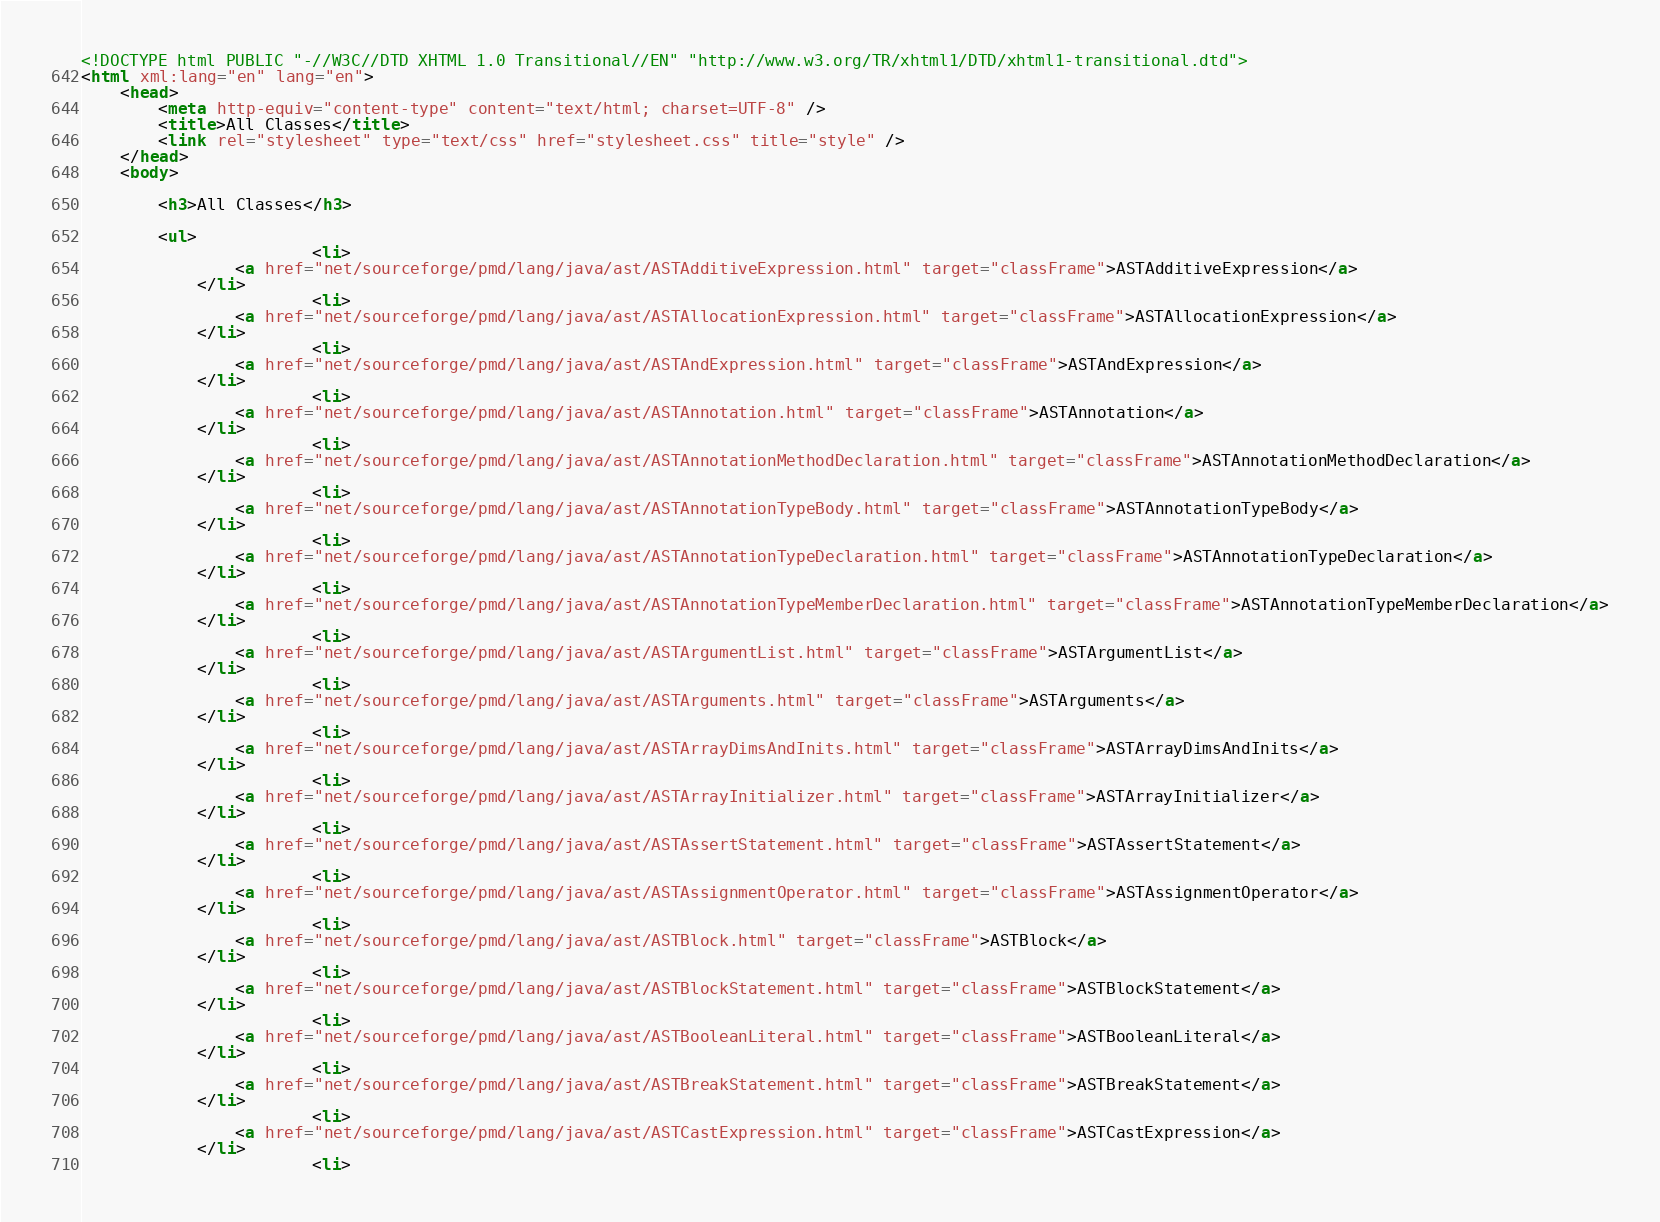Convert code to text. <code><loc_0><loc_0><loc_500><loc_500><_HTML_>
<!DOCTYPE html PUBLIC "-//W3C//DTD XHTML 1.0 Transitional//EN" "http://www.w3.org/TR/xhtml1/DTD/xhtml1-transitional.dtd">
<html xml:lang="en" lang="en">
	<head>
		<meta http-equiv="content-type" content="text/html; charset=UTF-8" />
		<title>All Classes</title>
		<link rel="stylesheet" type="text/css" href="stylesheet.css" title="style" />
    </head>
    <body>

		<h3>All Classes</h3>

		<ul>
						<li>
				<a href="net/sourceforge/pmd/lang/java/ast/ASTAdditiveExpression.html" target="classFrame">ASTAdditiveExpression</a>
			</li>
						<li>
				<a href="net/sourceforge/pmd/lang/java/ast/ASTAllocationExpression.html" target="classFrame">ASTAllocationExpression</a>
			</li>
						<li>
				<a href="net/sourceforge/pmd/lang/java/ast/ASTAndExpression.html" target="classFrame">ASTAndExpression</a>
			</li>
						<li>
				<a href="net/sourceforge/pmd/lang/java/ast/ASTAnnotation.html" target="classFrame">ASTAnnotation</a>
			</li>
						<li>
				<a href="net/sourceforge/pmd/lang/java/ast/ASTAnnotationMethodDeclaration.html" target="classFrame">ASTAnnotationMethodDeclaration</a>
			</li>
						<li>
				<a href="net/sourceforge/pmd/lang/java/ast/ASTAnnotationTypeBody.html" target="classFrame">ASTAnnotationTypeBody</a>
			</li>
						<li>
				<a href="net/sourceforge/pmd/lang/java/ast/ASTAnnotationTypeDeclaration.html" target="classFrame">ASTAnnotationTypeDeclaration</a>
			</li>
						<li>
				<a href="net/sourceforge/pmd/lang/java/ast/ASTAnnotationTypeMemberDeclaration.html" target="classFrame">ASTAnnotationTypeMemberDeclaration</a>
			</li>
						<li>
				<a href="net/sourceforge/pmd/lang/java/ast/ASTArgumentList.html" target="classFrame">ASTArgumentList</a>
			</li>
						<li>
				<a href="net/sourceforge/pmd/lang/java/ast/ASTArguments.html" target="classFrame">ASTArguments</a>
			</li>
						<li>
				<a href="net/sourceforge/pmd/lang/java/ast/ASTArrayDimsAndInits.html" target="classFrame">ASTArrayDimsAndInits</a>
			</li>
						<li>
				<a href="net/sourceforge/pmd/lang/java/ast/ASTArrayInitializer.html" target="classFrame">ASTArrayInitializer</a>
			</li>
						<li>
				<a href="net/sourceforge/pmd/lang/java/ast/ASTAssertStatement.html" target="classFrame">ASTAssertStatement</a>
			</li>
						<li>
				<a href="net/sourceforge/pmd/lang/java/ast/ASTAssignmentOperator.html" target="classFrame">ASTAssignmentOperator</a>
			</li>
						<li>
				<a href="net/sourceforge/pmd/lang/java/ast/ASTBlock.html" target="classFrame">ASTBlock</a>
			</li>
						<li>
				<a href="net/sourceforge/pmd/lang/java/ast/ASTBlockStatement.html" target="classFrame">ASTBlockStatement</a>
			</li>
						<li>
				<a href="net/sourceforge/pmd/lang/java/ast/ASTBooleanLiteral.html" target="classFrame">ASTBooleanLiteral</a>
			</li>
						<li>
				<a href="net/sourceforge/pmd/lang/java/ast/ASTBreakStatement.html" target="classFrame">ASTBreakStatement</a>
			</li>
						<li>
				<a href="net/sourceforge/pmd/lang/java/ast/ASTCastExpression.html" target="classFrame">ASTCastExpression</a>
			</li>
						<li></code> 